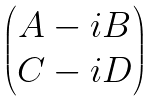Convert formula to latex. <formula><loc_0><loc_0><loc_500><loc_500>\begin{pmatrix} A - i B \\ C - i D \end{pmatrix}</formula> 